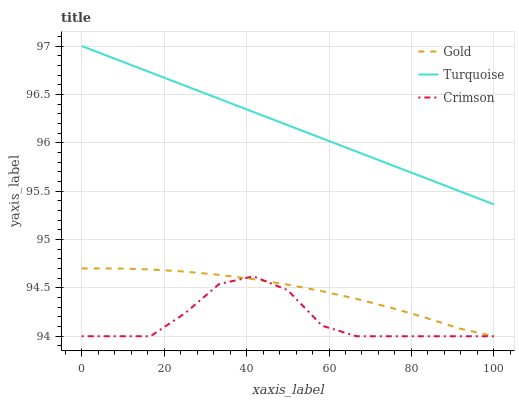Does Crimson have the minimum area under the curve?
Answer yes or no. Yes. Does Turquoise have the maximum area under the curve?
Answer yes or no. Yes. Does Gold have the minimum area under the curve?
Answer yes or no. No. Does Gold have the maximum area under the curve?
Answer yes or no. No. Is Turquoise the smoothest?
Answer yes or no. Yes. Is Crimson the roughest?
Answer yes or no. Yes. Is Gold the smoothest?
Answer yes or no. No. Is Gold the roughest?
Answer yes or no. No. Does Turquoise have the lowest value?
Answer yes or no. No. Does Gold have the highest value?
Answer yes or no. No. Is Crimson less than Turquoise?
Answer yes or no. Yes. Is Turquoise greater than Crimson?
Answer yes or no. Yes. Does Crimson intersect Turquoise?
Answer yes or no. No. 